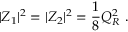<formula> <loc_0><loc_0><loc_500><loc_500>| Z _ { 1 } | ^ { 2 } = | Z _ { 2 } | ^ { 2 } = { \frac { 1 } { 8 } } Q _ { R } ^ { 2 } \ .</formula> 